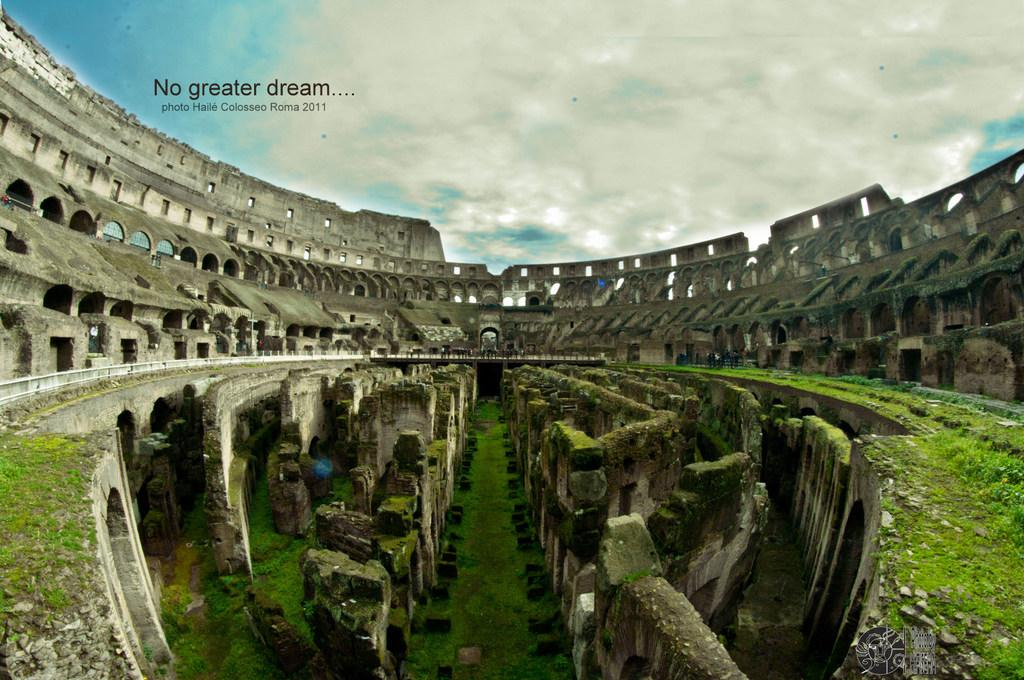What type of structure is depicted in the image? There is an ancient monument in the image. What can be seen in the sky in the image? There are clouds in the sky. Where is the text located in the image? The text is in the top left of the image. What color is the crayon used to draw the curve in the image? There is no crayon or curve present in the image. What type of home is visible in the image? There is no home visible in the image; it features an ancient monument and clouds in the sky. 